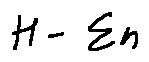Convert formula to latex. <formula><loc_0><loc_0><loc_500><loc_500>H - \sum n</formula> 